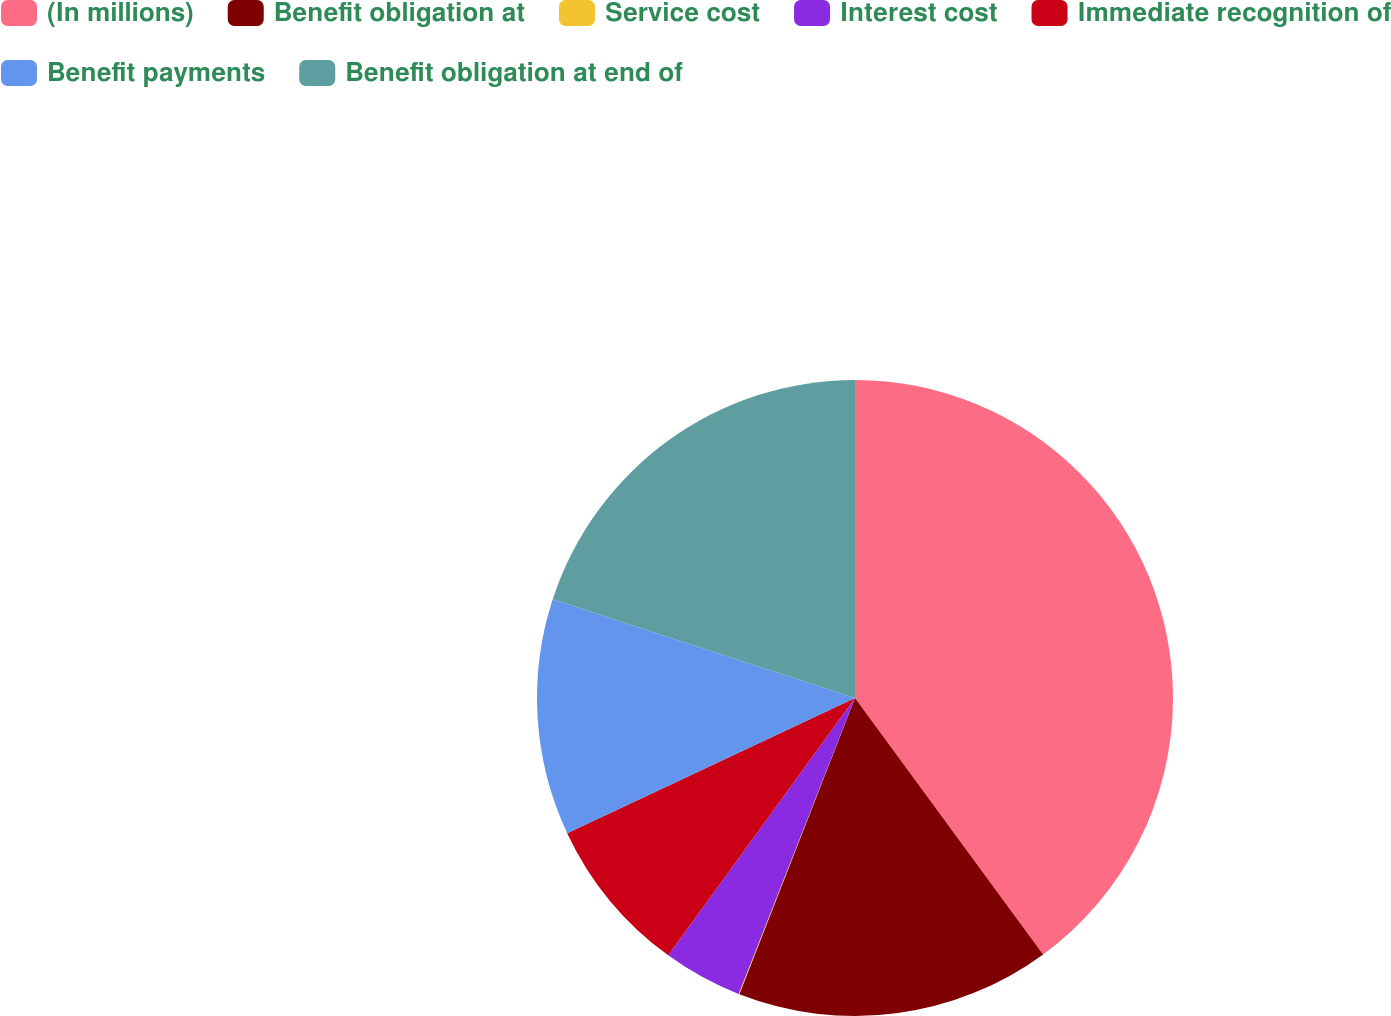Convert chart. <chart><loc_0><loc_0><loc_500><loc_500><pie_chart><fcel>(In millions)<fcel>Benefit obligation at<fcel>Service cost<fcel>Interest cost<fcel>Immediate recognition of<fcel>Benefit payments<fcel>Benefit obligation at end of<nl><fcel>39.93%<fcel>16.0%<fcel>0.04%<fcel>4.03%<fcel>8.02%<fcel>12.01%<fcel>19.98%<nl></chart> 